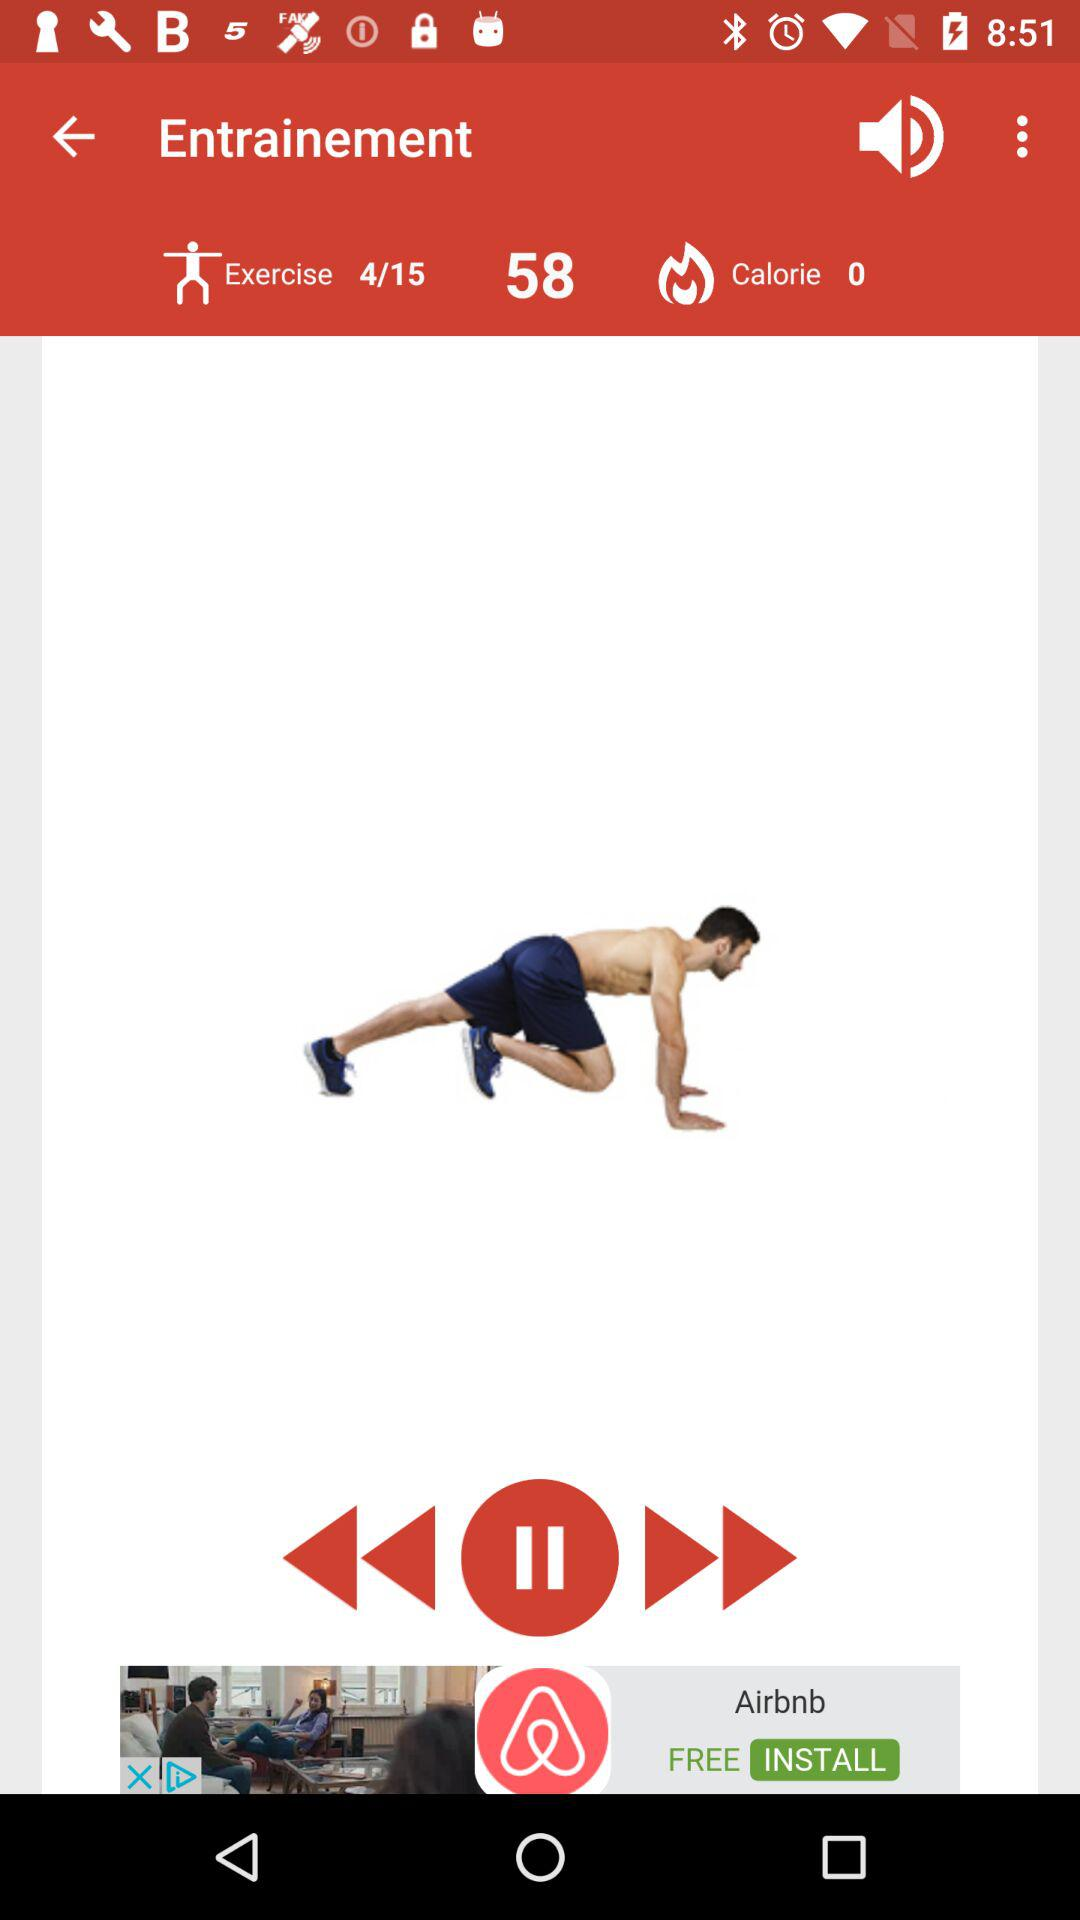How many more exercises are there to complete?
Answer the question using a single word or phrase. 11 